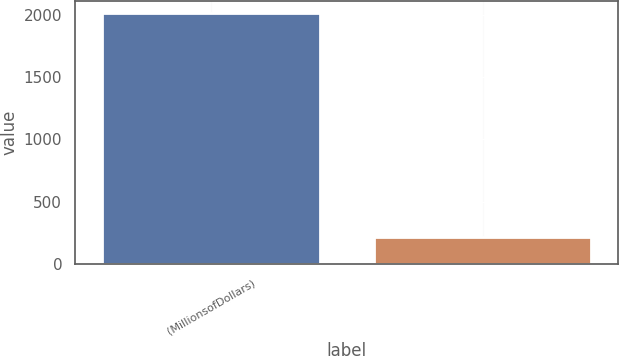<chart> <loc_0><loc_0><loc_500><loc_500><bar_chart><fcel>(MillionsofDollars)<fcel>Unnamed: 1<nl><fcel>2010<fcel>219.72<nl></chart> 